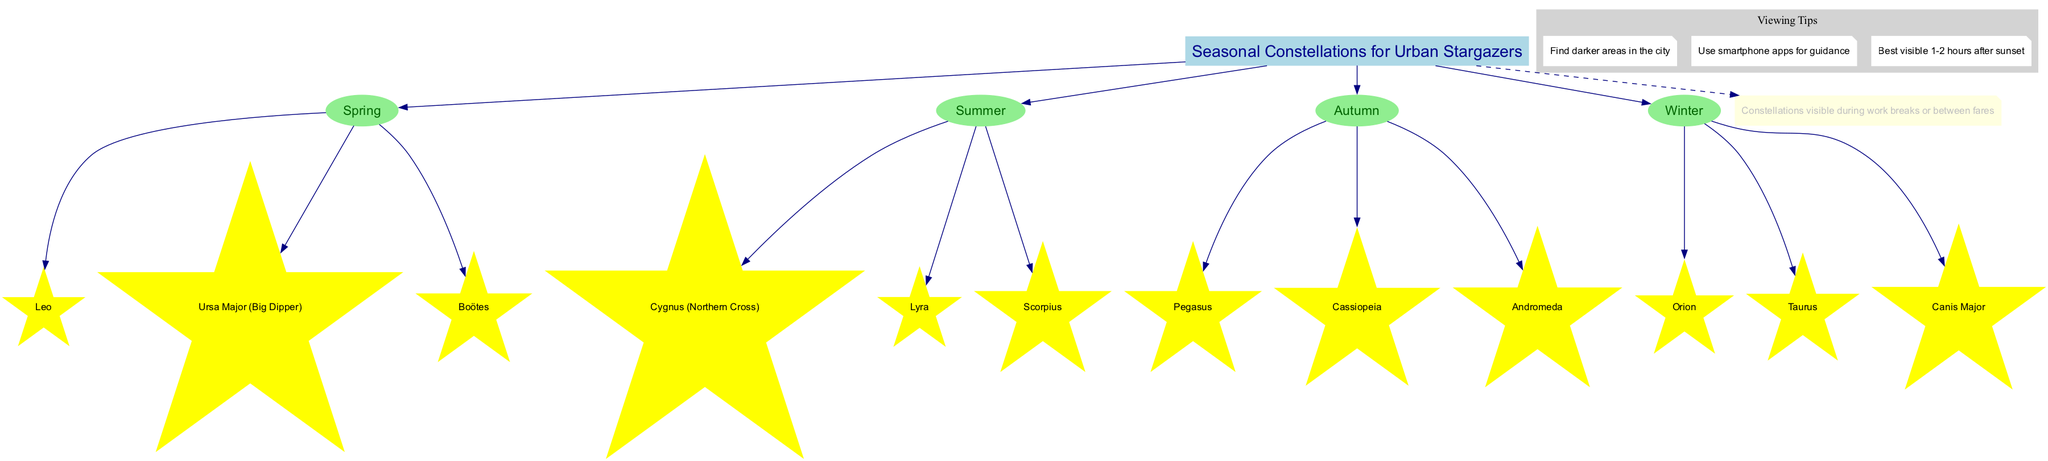What are the constellations visible in Spring? The diagram lists three constellations under the Spring section: Leo, Ursa Major (Big Dipper), and Boötes.
Answer: Leo, Ursa Major (Big Dipper), Boötes How many constellations are shown for Summer? The Summer section of the diagram includes three constellations: Cygnus (Northern Cross), Lyra, and Scorpius. Counting these yields a total of three.
Answer: 3 Which season features Orion? Orion is listed under the Winter section of the diagram, indicating that it is a constellation visible during Winter.
Answer: Winter What are the viewing tips mentioned in the diagram? The diagram provides three viewing tips. They are: "Find darker areas in the city," "Use smartphone apps for guidance," and "Best visible 1-2 hours after sunset."
Answer: Find darker areas, Use smartphone apps, Best visible 1-2 hours after sunset In which season is Pegasus visible? According to the diagram, Pegasus is visible during the Autumn season, as it is grouped with other constellations in this section.
Answer: Autumn Which constellation corresponds to the Northern Cross? The diagram identifies Cygnus as the constellation that corresponds to the Northern Cross, which is listed under the Summer season.
Answer: Cygnus How many seasons are represented in the diagram? The diagram includes four seasons: Spring, Summer, Autumn, and Winter. Counting these gives a total of four.
Answer: 4 Which constellation is visible during work breaks or between fares? The note in the diagram specifically mentions that the constellations listed are visible during work breaks or between fares, implying they can be viewed at different times across the categories listed.
Answer: All constellations Which color identifies the constellations in the diagram? The constellations in the diagram are represented by yellow star-shaped nodes, indicating that yellow is the color used to identify them visually.
Answer: Yellow 